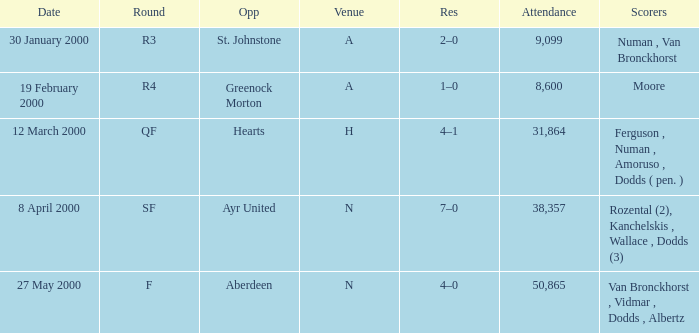Who was in a with opponent St. Johnstone? Numan , Van Bronckhorst. 